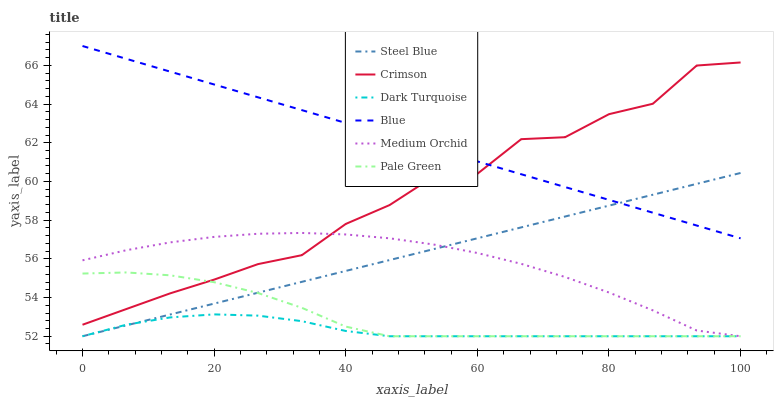Does Dark Turquoise have the minimum area under the curve?
Answer yes or no. Yes. Does Blue have the maximum area under the curve?
Answer yes or no. Yes. Does Medium Orchid have the minimum area under the curve?
Answer yes or no. No. Does Medium Orchid have the maximum area under the curve?
Answer yes or no. No. Is Steel Blue the smoothest?
Answer yes or no. Yes. Is Crimson the roughest?
Answer yes or no. Yes. Is Dark Turquoise the smoothest?
Answer yes or no. No. Is Dark Turquoise the roughest?
Answer yes or no. No. Does Crimson have the lowest value?
Answer yes or no. No. Does Blue have the highest value?
Answer yes or no. Yes. Does Medium Orchid have the highest value?
Answer yes or no. No. Is Dark Turquoise less than Blue?
Answer yes or no. Yes. Is Crimson greater than Dark Turquoise?
Answer yes or no. Yes. Does Blue intersect Crimson?
Answer yes or no. Yes. Is Blue less than Crimson?
Answer yes or no. No. Is Blue greater than Crimson?
Answer yes or no. No. Does Dark Turquoise intersect Blue?
Answer yes or no. No. 